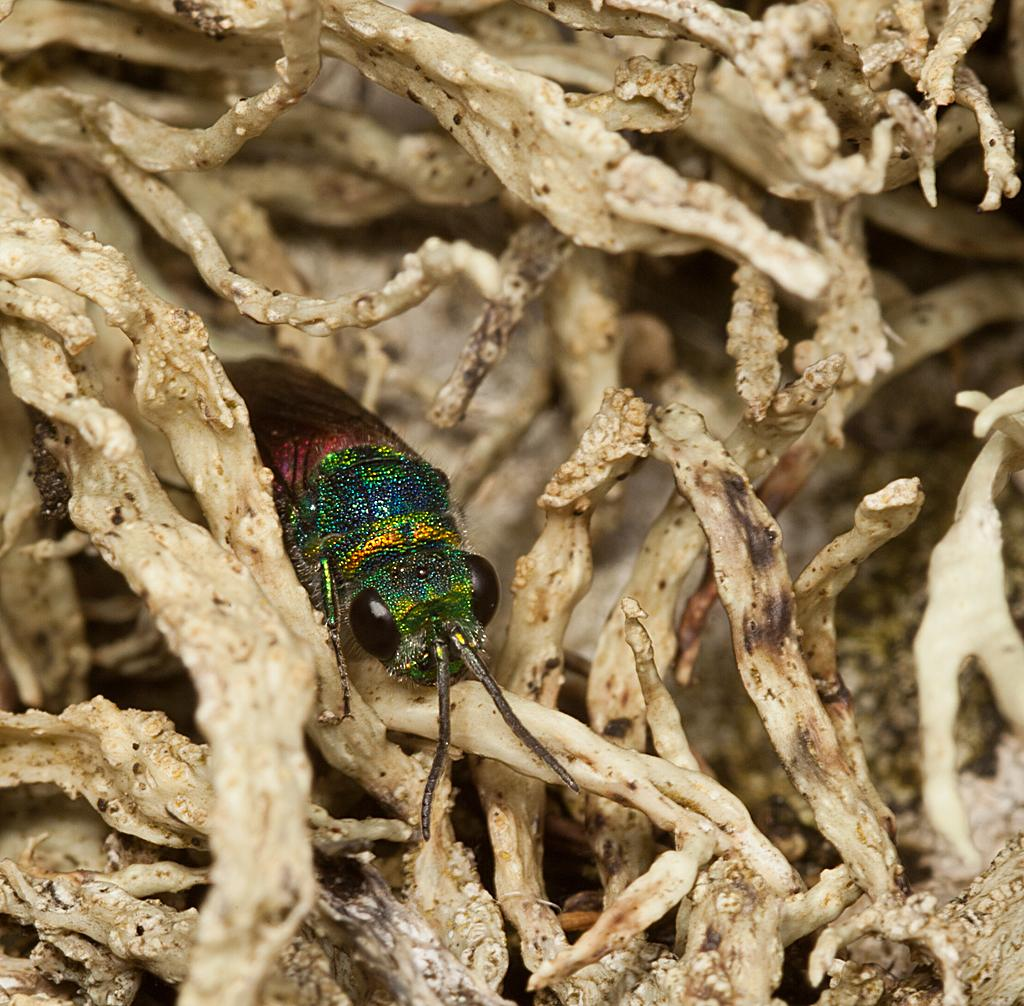What is the main subject of the image? There is an insect in the center of the image. What can be seen in the background of the image? There are dry leaves in the background of the image. What type of magic is the insect performing in the image? There is no magic or magical activity depicted in the image; it simply shows an insect in the center of the image. What kind of metal can be seen in the image? There is no metal present in the image; it features an insect and dry leaves in the background. 